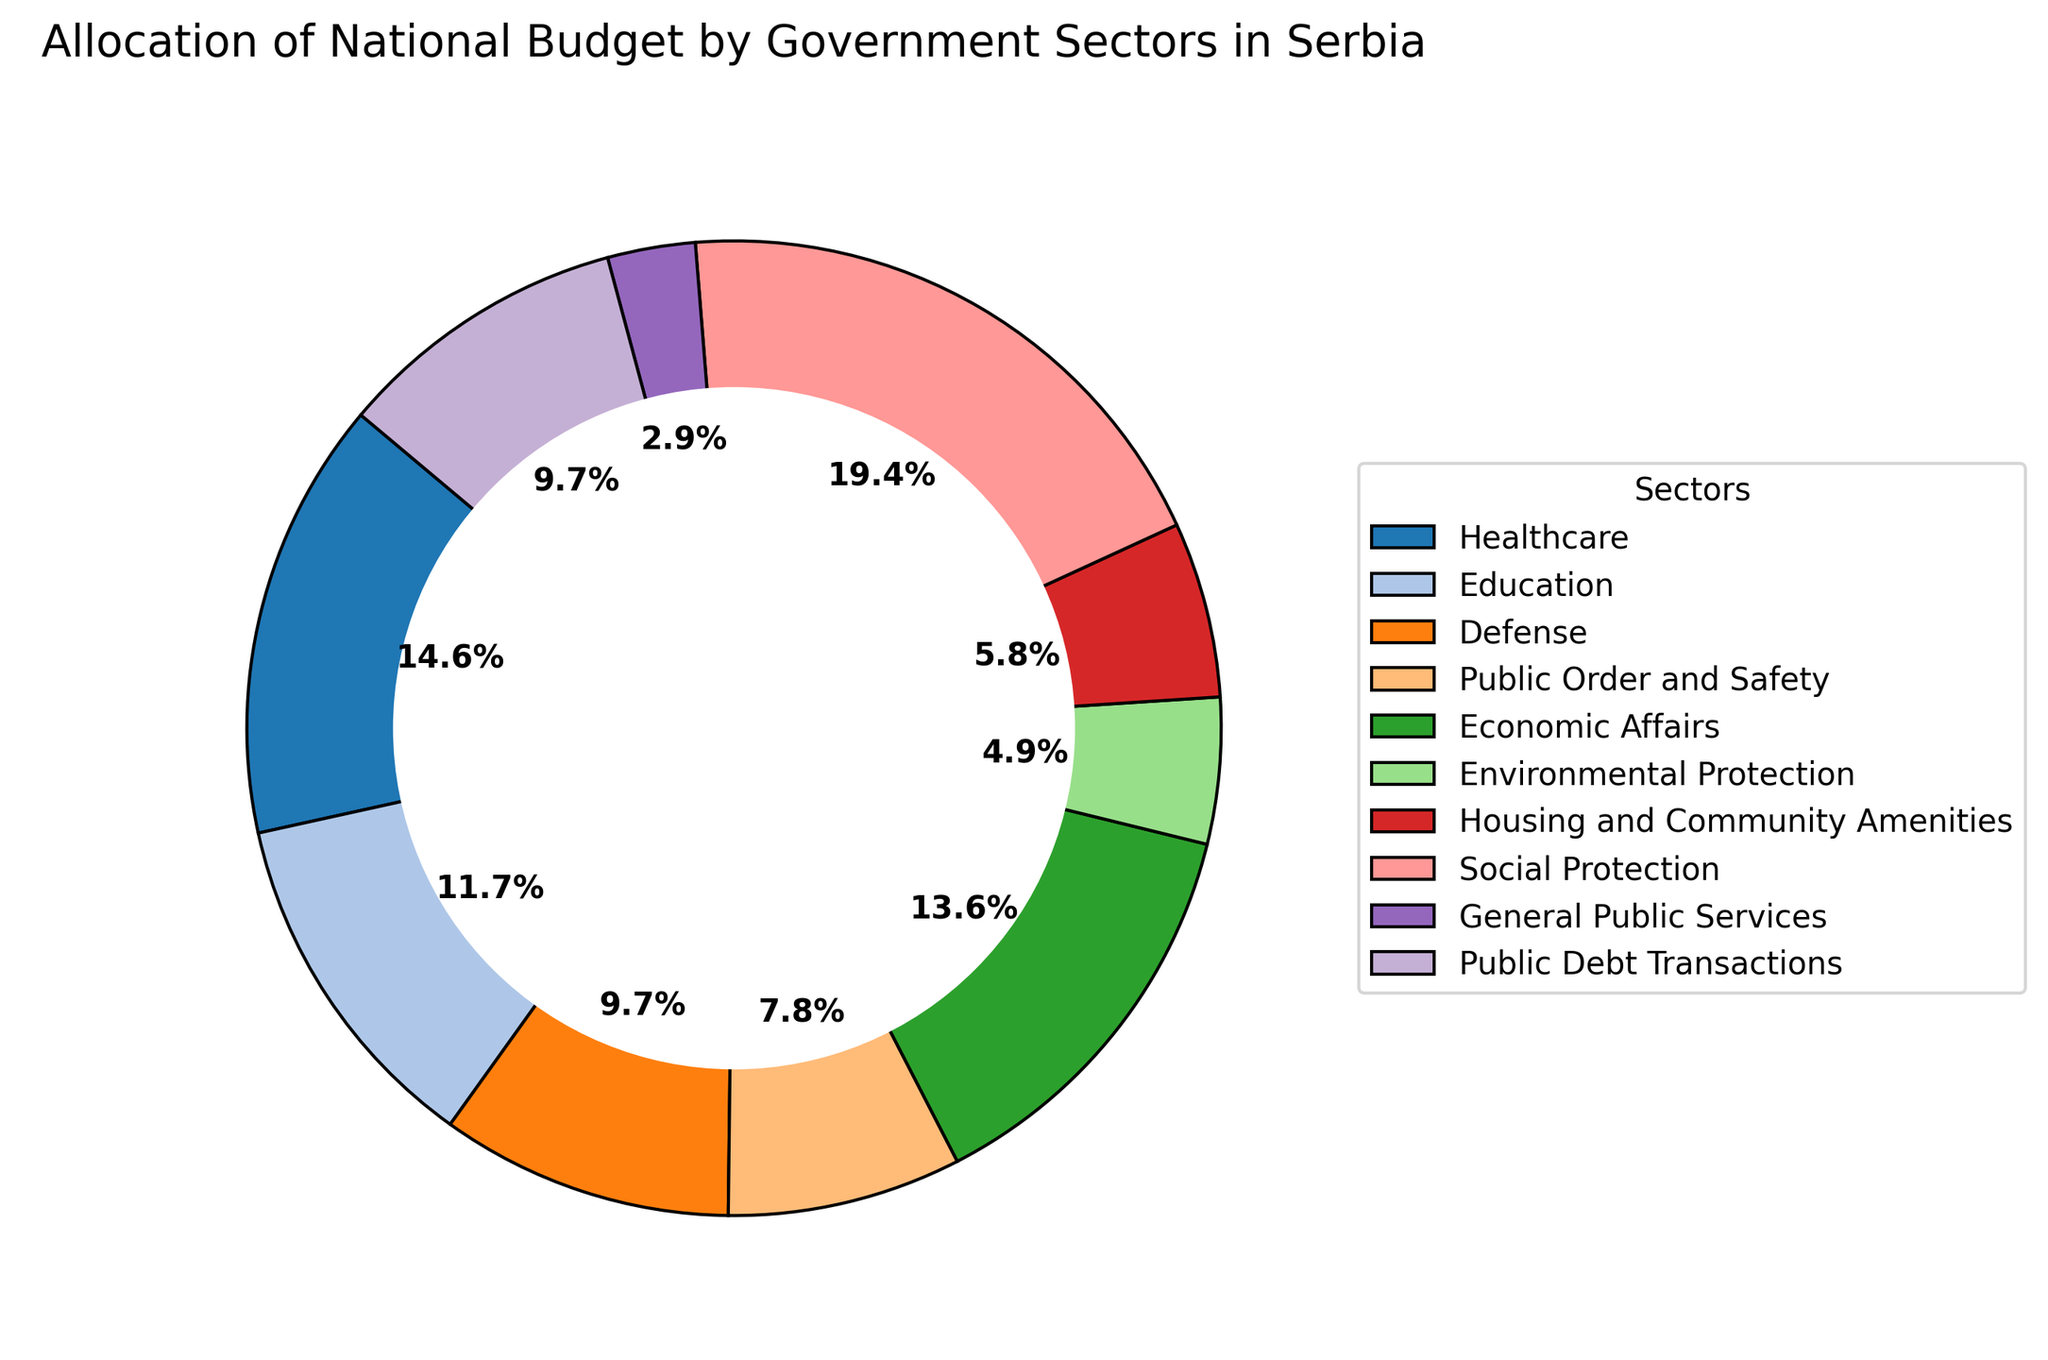What percentage of the budget is allocated to Healthcare and Education combined? First, locate the percentages for Healthcare (15%) and Education (12%) in the pie chart. Then, add these two percentages together: 15% + 12% = 27%.
Answer: 27% Which sector has the smallest allocation, and what percentage does it receive? Find the smallest wedge in the pie chart. The smallest portion is labeled "General Public Services" and it receives 3% of the budget.
Answer: General Public Services - 3% Compare the allocation of Public Order and Safety to Housing and Community Amenities. Which one gets a larger budget percentage, and by how much? Find the percentages for both sectors: Public Order and Safety (8%) and Housing and Community Amenities (6%). Subtract the smaller percentage from the larger one: 8% - 6% = 2%.
Answer: Public Order and Safety by 2% What is the total percentage allocated to Social Protection, Economic Affairs, and Housing and Community Amenities? Add the percentages of the three sectors: Social Protection (20%), Economic Affairs (14%), and Housing and Community Amenities (6%): 20% + 14% + 6% = 40%.
Answer: 40% How does the percentage allocated to Defense compare to Public Debt Transactions? Which one has a higher allocation? Look at the percentages for both sectors: Defense (10%) and Public Debt Transactions (10%). Since they are equal, neither sector has a higher allocation.
Answer: Both are equal Among Social Protection, Healthcare, and Education, which sector receives the greatest share of the budget? Compare the percentages for these three sectors: Social Protection (20%), Healthcare (15%), and Education (12%). The greatest percentage is for Social Protection at 20%.
Answer: Social Protection What is the combined percentage of all sectors excluding Social Protection and Public Debt Transactions? First, note the total percentage of Social Protection (20%) and Public Debt Transactions (10%). The entire budget is 100%, so subtract the percentage of these sectors: 100% - 20% - 10% = 70%.
Answer: 70% Identify the sector with the highest allocation and the sector with the lowest allocation. Find the highest and lowest percentages in the pie chart. The highest allocation goes to Social Protection (20%), and the lowest to General Public Services (3%).
Answer: Social Protection (highest) and General Public Services (lowest) How much more is allocated to Healthcare compared to Environmental Protection? Locate the percentages: Healthcare (15%) and Environmental Protection (5%). Subtract the smaller percentage from the larger: 15% - 5% = 10%.
Answer: 10% What is the visual difference in the sizes of wedges between Economic Affairs and Education? Find the wedges corresponding to Economic Affairs (14%) and Education (12%). The wedge for Economic Affairs is larger by 2%.
Answer: Economic Affairs is larger by 2% 